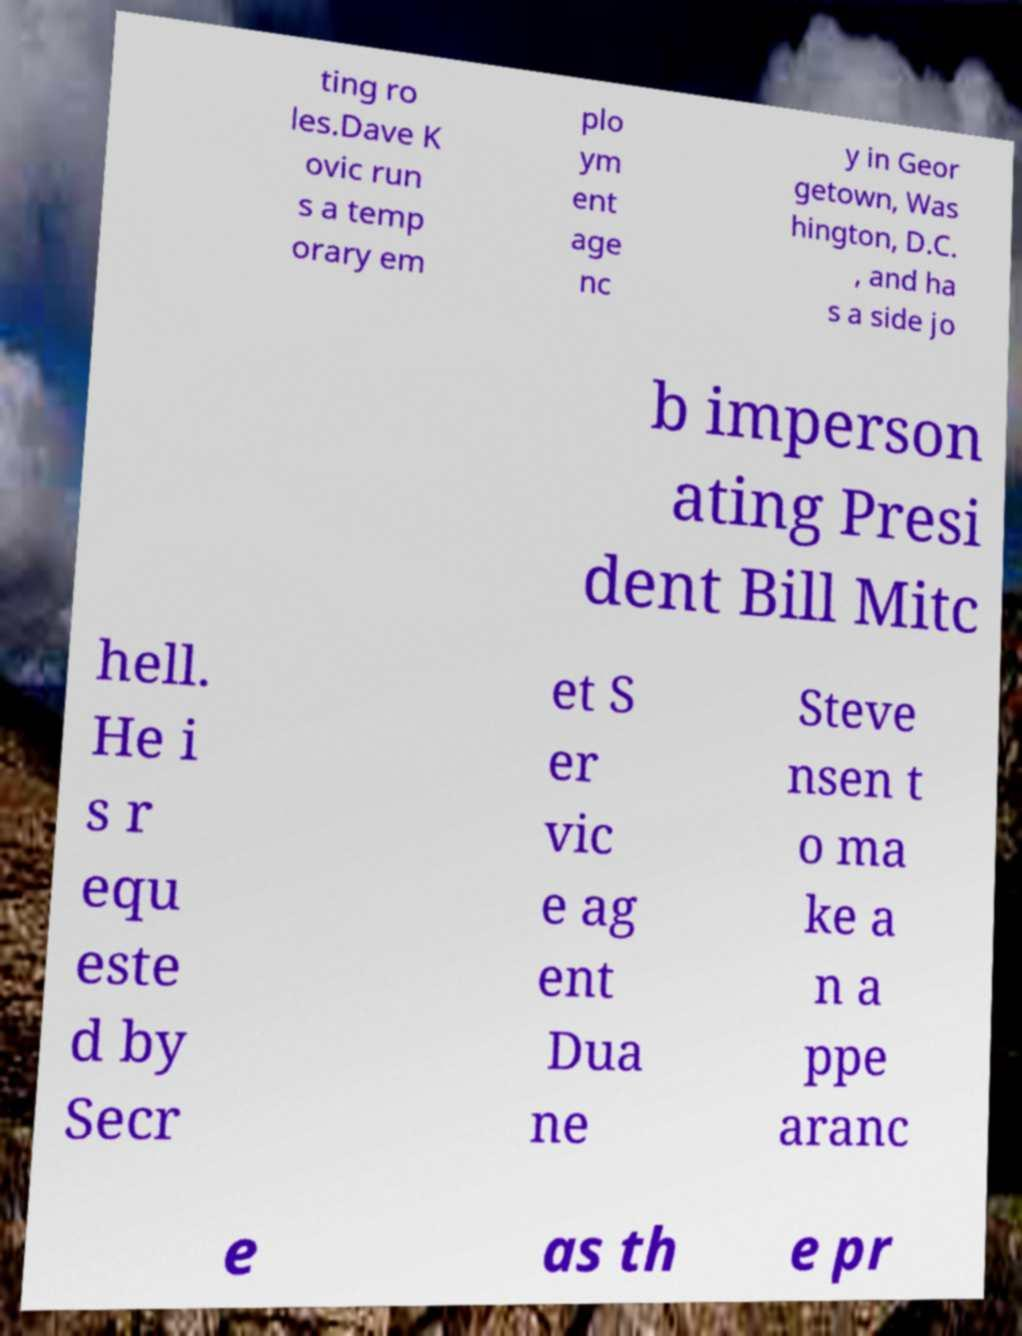There's text embedded in this image that I need extracted. Can you transcribe it verbatim? ting ro les.Dave K ovic run s a temp orary em plo ym ent age nc y in Geor getown, Was hington, D.C. , and ha s a side jo b imperson ating Presi dent Bill Mitc hell. He i s r equ este d by Secr et S er vic e ag ent Dua ne Steve nsen t o ma ke a n a ppe aranc e as th e pr 